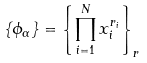Convert formula to latex. <formula><loc_0><loc_0><loc_500><loc_500>\{ \phi _ { \alpha } \} = \left \{ \prod _ { i = 1 } ^ { N } x _ { i } ^ { r _ { i } } \right \} _ { r }</formula> 